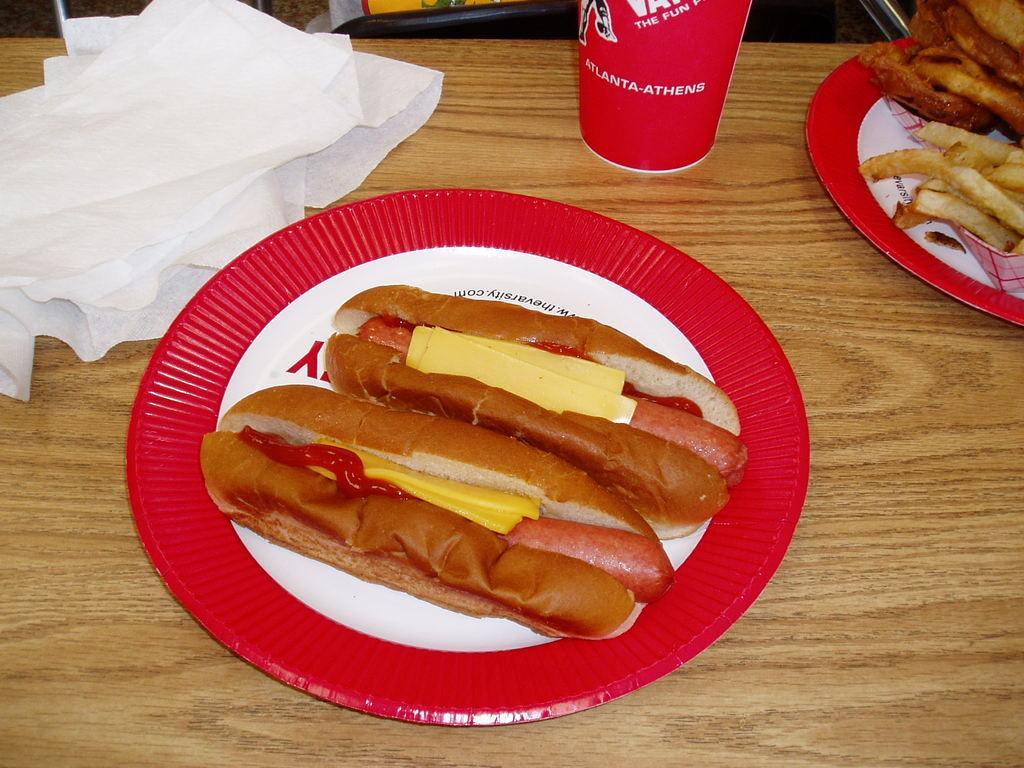How would you summarize this image in a sentence or two? In this picture we can see a table, there are two plates, a glass and papers present on the table, we can see two hot dogs in this plate, we can see finger chips in this plate. 